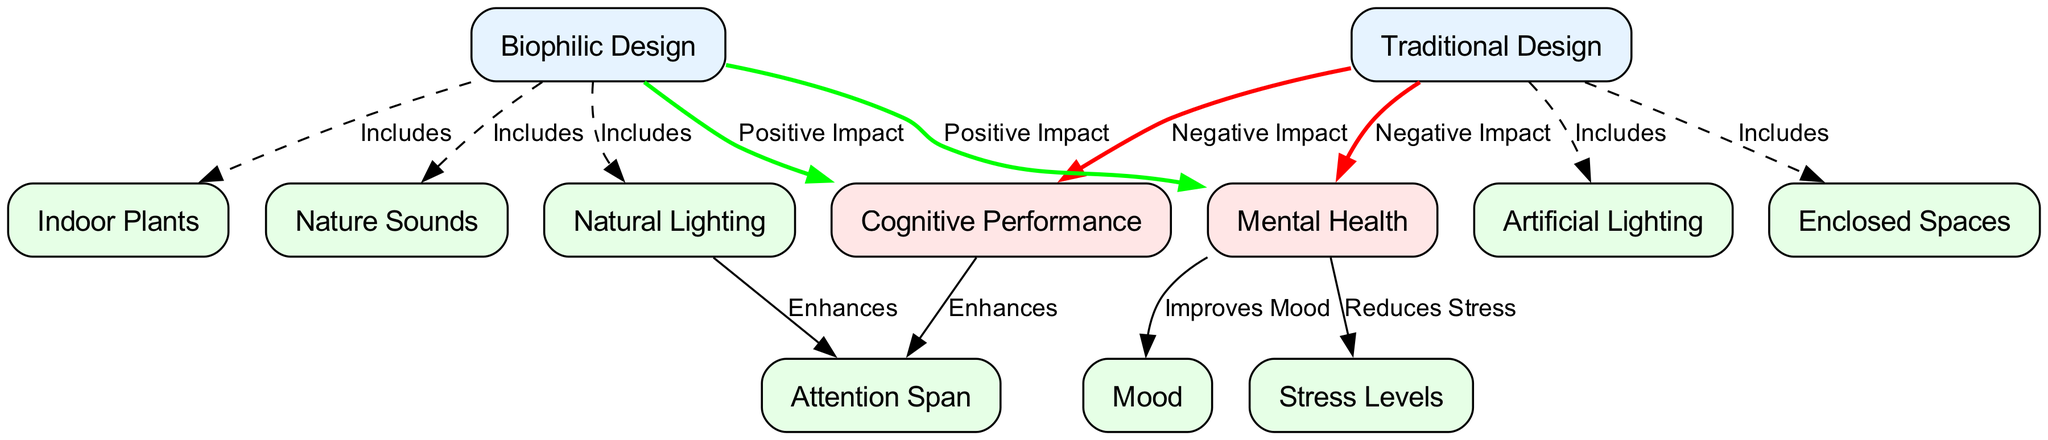What are the two main design types compared in the diagram? The diagram compares "Traditional Design" and "Biophilic Design," which are clearly labeled as nodes in the diagram.
Answer: Traditional Design, Biophilic Design How many edges connect to the "Mental Health" node? The "Mental Health" node has three edges connecting it to other nodes: two from "Biophilic Design" and one to "Stress Levels" and another to "Mood."
Answer: 4 What is the relationship between "Traditional Design" and "Cognitive Performance"? The edge connecting "Traditional Design" to "Cognitive Performance" is labeled "Negative Impact," indicating a detrimental effect of traditional design on cognitive performance.
Answer: Negative Impact Which design type is associated with "Natural Lighting"? The "Natural Lighting" node has an edge connecting it to "Biophilic Design," indicating that biophilic design includes natural lighting as a feature.
Answer: Biophilic Design How does "Biophilic Design" impact "Mental Health"? The node shows a positive relationship with "Mental Health," as indicated by the edge labeled "Positive Impact" connecting "Biophilic Design" to "Mental Health."
Answer: Positive Impact What features are unique to "Traditional Design"? The edges labeled "Includes" show that "Traditional Design" includes "Artificial Lighting" and "Enclosed Spaces," indicating its unique characteristics.
Answer: Artificial Lighting, Enclosed Spaces What specific impact does "Cognitive Performance" have on "Attention Span"? The edge from "Cognitive Performance" directly enhances "Attention Span," showing a positive influence in the relationship.
Answer: Enhances How many features does "Biophilic Design" include? The diagram indicates that "Biophilic Design" includes three features: "Natural Lighting," "Indoor Plants," and "Nature Sounds," evidenced by the three edges connected to it.
Answer: 3 What effect does "Mental Health" have on "Mood"? There is an edge labeled "Improves Mood" that connects "Mental Health" to "Mood," indicating a positive effect on mood.
Answer: Improves Mood 